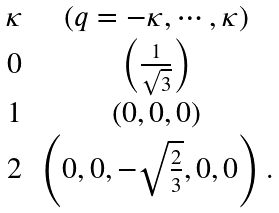Convert formula to latex. <formula><loc_0><loc_0><loc_500><loc_500>\begin{array} { c c } \kappa & ( q = - \kappa , \cdots , \kappa ) \\ 0 & \left ( \frac { 1 } { \sqrt { 3 } } \right ) \\ 1 & \left ( 0 , 0 , 0 \right ) \\ 2 & \left ( 0 , 0 , - \sqrt { \frac { 2 } { 3 } } , 0 , 0 \right ) . \end{array}</formula> 